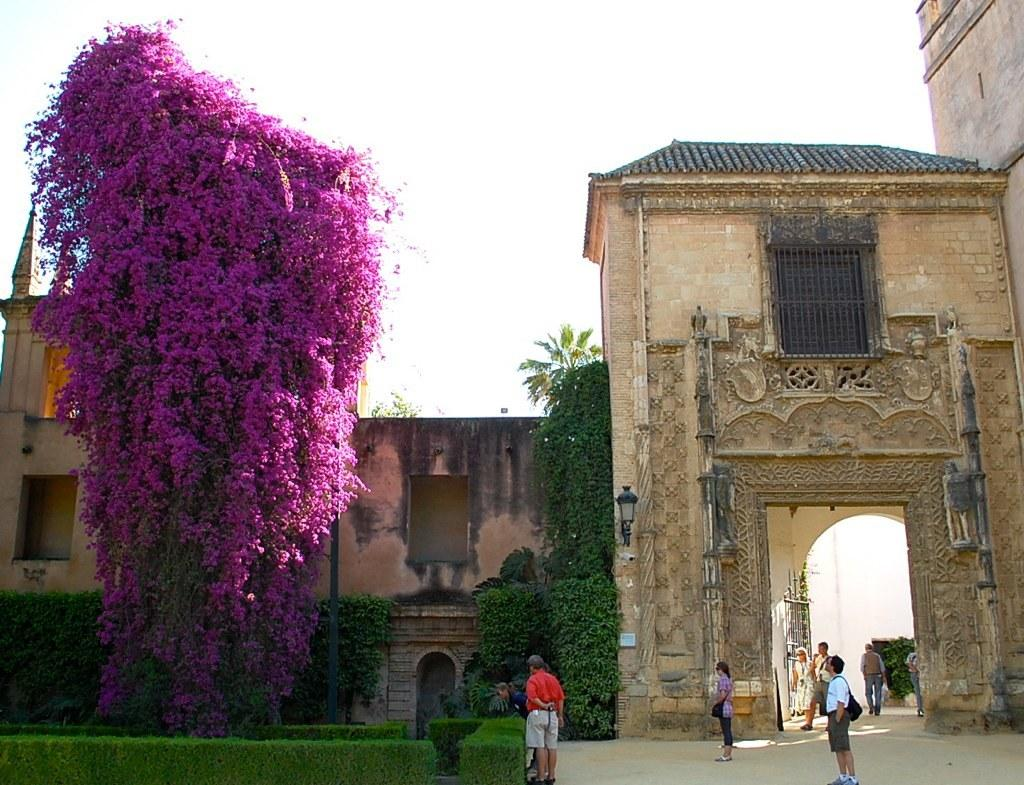What can be seen in the foreground of the image? There are people standing in the foreground of the image. Where are the people standing? The people are standing on the ground. What type of vegetation is present in the image? There are plants and flowers in the image. What type of structure is visible in the image? There is a building in the image. What is visible in the background of the image? The sky is visible in the image. What type of potato is being used as a decoration in the image? There is no potato present in the image; it features people, plants, flowers, a building, and the sky. 